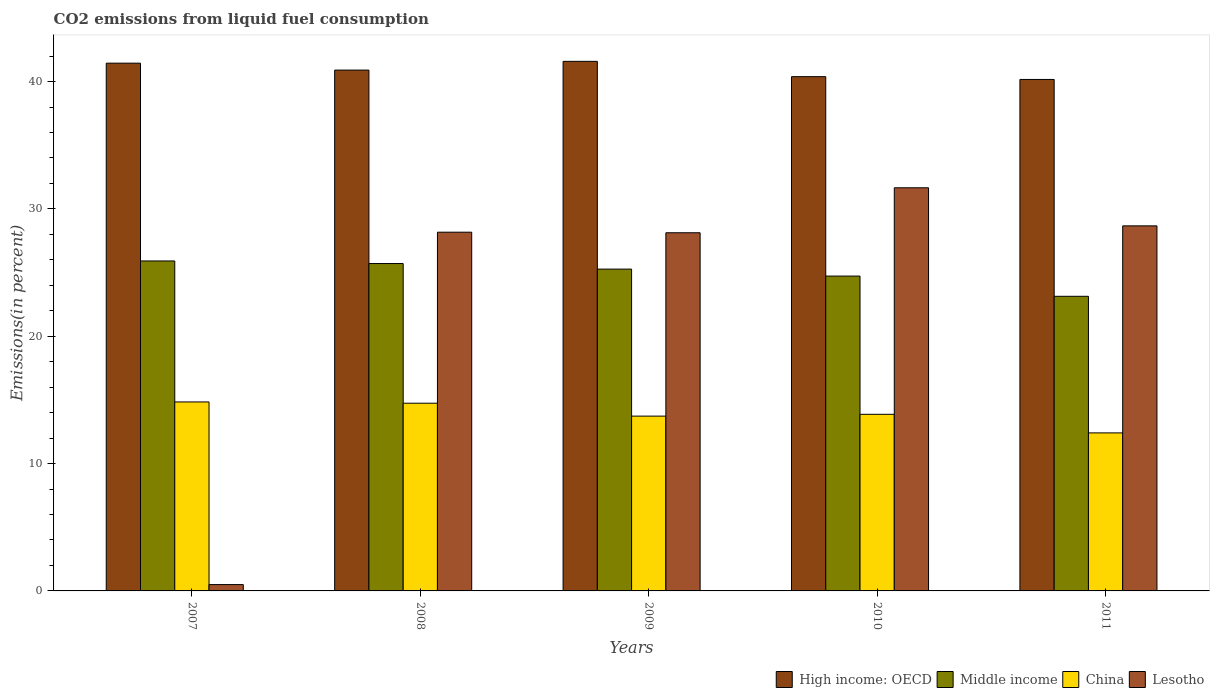How many groups of bars are there?
Provide a succinct answer. 5. Are the number of bars per tick equal to the number of legend labels?
Ensure brevity in your answer.  Yes. How many bars are there on the 1st tick from the left?
Make the answer very short. 4. How many bars are there on the 2nd tick from the right?
Your response must be concise. 4. What is the label of the 5th group of bars from the left?
Give a very brief answer. 2011. In how many cases, is the number of bars for a given year not equal to the number of legend labels?
Offer a terse response. 0. What is the total CO2 emitted in High income: OECD in 2011?
Your answer should be compact. 40.16. Across all years, what is the maximum total CO2 emitted in Lesotho?
Your response must be concise. 31.66. Across all years, what is the minimum total CO2 emitted in China?
Make the answer very short. 12.41. In which year was the total CO2 emitted in Lesotho maximum?
Offer a very short reply. 2010. In which year was the total CO2 emitted in China minimum?
Ensure brevity in your answer.  2011. What is the total total CO2 emitted in China in the graph?
Keep it short and to the point. 69.58. What is the difference between the total CO2 emitted in High income: OECD in 2008 and that in 2011?
Provide a succinct answer. 0.74. What is the difference between the total CO2 emitted in Lesotho in 2008 and the total CO2 emitted in Middle income in 2010?
Make the answer very short. 3.45. What is the average total CO2 emitted in China per year?
Give a very brief answer. 13.92. In the year 2007, what is the difference between the total CO2 emitted in China and total CO2 emitted in Middle income?
Provide a short and direct response. -11.07. In how many years, is the total CO2 emitted in China greater than 20 %?
Your answer should be compact. 0. What is the ratio of the total CO2 emitted in Lesotho in 2008 to that in 2011?
Your answer should be very brief. 0.98. Is the difference between the total CO2 emitted in China in 2009 and 2010 greater than the difference between the total CO2 emitted in Middle income in 2009 and 2010?
Provide a short and direct response. No. What is the difference between the highest and the second highest total CO2 emitted in China?
Offer a very short reply. 0.1. What is the difference between the highest and the lowest total CO2 emitted in Lesotho?
Make the answer very short. 31.16. Is the sum of the total CO2 emitted in Middle income in 2008 and 2009 greater than the maximum total CO2 emitted in High income: OECD across all years?
Your answer should be very brief. Yes. What does the 2nd bar from the left in 2008 represents?
Ensure brevity in your answer.  Middle income. What does the 1st bar from the right in 2011 represents?
Offer a terse response. Lesotho. How many bars are there?
Provide a succinct answer. 20. Are all the bars in the graph horizontal?
Your answer should be very brief. No. Are the values on the major ticks of Y-axis written in scientific E-notation?
Ensure brevity in your answer.  No. Does the graph contain any zero values?
Your answer should be very brief. No. How many legend labels are there?
Provide a succinct answer. 4. What is the title of the graph?
Your answer should be compact. CO2 emissions from liquid fuel consumption. What is the label or title of the X-axis?
Provide a succinct answer. Years. What is the label or title of the Y-axis?
Your answer should be very brief. Emissions(in percent). What is the Emissions(in percent) of High income: OECD in 2007?
Offer a very short reply. 41.44. What is the Emissions(in percent) in Middle income in 2007?
Offer a very short reply. 25.91. What is the Emissions(in percent) of China in 2007?
Ensure brevity in your answer.  14.84. What is the Emissions(in percent) in Lesotho in 2007?
Provide a short and direct response. 0.5. What is the Emissions(in percent) in High income: OECD in 2008?
Your answer should be compact. 40.9. What is the Emissions(in percent) in Middle income in 2008?
Your answer should be compact. 25.71. What is the Emissions(in percent) of China in 2008?
Ensure brevity in your answer.  14.74. What is the Emissions(in percent) of Lesotho in 2008?
Make the answer very short. 28.17. What is the Emissions(in percent) of High income: OECD in 2009?
Offer a terse response. 41.58. What is the Emissions(in percent) in Middle income in 2009?
Your response must be concise. 25.27. What is the Emissions(in percent) of China in 2009?
Your answer should be very brief. 13.73. What is the Emissions(in percent) in Lesotho in 2009?
Offer a very short reply. 28.12. What is the Emissions(in percent) of High income: OECD in 2010?
Provide a succinct answer. 40.38. What is the Emissions(in percent) of Middle income in 2010?
Offer a very short reply. 24.72. What is the Emissions(in percent) of China in 2010?
Give a very brief answer. 13.87. What is the Emissions(in percent) in Lesotho in 2010?
Your answer should be very brief. 31.66. What is the Emissions(in percent) in High income: OECD in 2011?
Your answer should be compact. 40.16. What is the Emissions(in percent) in Middle income in 2011?
Give a very brief answer. 23.13. What is the Emissions(in percent) in China in 2011?
Your response must be concise. 12.41. What is the Emissions(in percent) in Lesotho in 2011?
Offer a very short reply. 28.67. Across all years, what is the maximum Emissions(in percent) in High income: OECD?
Provide a short and direct response. 41.58. Across all years, what is the maximum Emissions(in percent) of Middle income?
Make the answer very short. 25.91. Across all years, what is the maximum Emissions(in percent) of China?
Your response must be concise. 14.84. Across all years, what is the maximum Emissions(in percent) of Lesotho?
Keep it short and to the point. 31.66. Across all years, what is the minimum Emissions(in percent) of High income: OECD?
Make the answer very short. 40.16. Across all years, what is the minimum Emissions(in percent) in Middle income?
Keep it short and to the point. 23.13. Across all years, what is the minimum Emissions(in percent) in China?
Give a very brief answer. 12.41. Across all years, what is the minimum Emissions(in percent) in Lesotho?
Offer a terse response. 0.5. What is the total Emissions(in percent) in High income: OECD in the graph?
Ensure brevity in your answer.  204.47. What is the total Emissions(in percent) in Middle income in the graph?
Your response must be concise. 124.75. What is the total Emissions(in percent) of China in the graph?
Your answer should be compact. 69.58. What is the total Emissions(in percent) in Lesotho in the graph?
Keep it short and to the point. 117.11. What is the difference between the Emissions(in percent) in High income: OECD in 2007 and that in 2008?
Provide a short and direct response. 0.54. What is the difference between the Emissions(in percent) in Middle income in 2007 and that in 2008?
Provide a short and direct response. 0.2. What is the difference between the Emissions(in percent) of China in 2007 and that in 2008?
Ensure brevity in your answer.  0.1. What is the difference between the Emissions(in percent) in Lesotho in 2007 and that in 2008?
Your answer should be compact. -27.67. What is the difference between the Emissions(in percent) in High income: OECD in 2007 and that in 2009?
Your answer should be very brief. -0.14. What is the difference between the Emissions(in percent) in Middle income in 2007 and that in 2009?
Offer a terse response. 0.64. What is the difference between the Emissions(in percent) in China in 2007 and that in 2009?
Offer a very short reply. 1.11. What is the difference between the Emissions(in percent) in Lesotho in 2007 and that in 2009?
Make the answer very short. -27.63. What is the difference between the Emissions(in percent) of High income: OECD in 2007 and that in 2010?
Provide a succinct answer. 1.06. What is the difference between the Emissions(in percent) of Middle income in 2007 and that in 2010?
Make the answer very short. 1.19. What is the difference between the Emissions(in percent) of China in 2007 and that in 2010?
Make the answer very short. 0.97. What is the difference between the Emissions(in percent) of Lesotho in 2007 and that in 2010?
Your answer should be compact. -31.16. What is the difference between the Emissions(in percent) in High income: OECD in 2007 and that in 2011?
Your response must be concise. 1.28. What is the difference between the Emissions(in percent) in Middle income in 2007 and that in 2011?
Your response must be concise. 2.78. What is the difference between the Emissions(in percent) in China in 2007 and that in 2011?
Offer a terse response. 2.43. What is the difference between the Emissions(in percent) in Lesotho in 2007 and that in 2011?
Offer a very short reply. -28.17. What is the difference between the Emissions(in percent) in High income: OECD in 2008 and that in 2009?
Provide a succinct answer. -0.69. What is the difference between the Emissions(in percent) of Middle income in 2008 and that in 2009?
Your answer should be very brief. 0.44. What is the difference between the Emissions(in percent) of China in 2008 and that in 2009?
Make the answer very short. 1.01. What is the difference between the Emissions(in percent) of Lesotho in 2008 and that in 2009?
Your answer should be very brief. 0.04. What is the difference between the Emissions(in percent) in High income: OECD in 2008 and that in 2010?
Keep it short and to the point. 0.52. What is the difference between the Emissions(in percent) of Middle income in 2008 and that in 2010?
Offer a terse response. 0.98. What is the difference between the Emissions(in percent) of China in 2008 and that in 2010?
Offer a terse response. 0.87. What is the difference between the Emissions(in percent) in Lesotho in 2008 and that in 2010?
Give a very brief answer. -3.49. What is the difference between the Emissions(in percent) of High income: OECD in 2008 and that in 2011?
Ensure brevity in your answer.  0.74. What is the difference between the Emissions(in percent) of Middle income in 2008 and that in 2011?
Provide a succinct answer. 2.57. What is the difference between the Emissions(in percent) in China in 2008 and that in 2011?
Make the answer very short. 2.33. What is the difference between the Emissions(in percent) in Lesotho in 2008 and that in 2011?
Keep it short and to the point. -0.5. What is the difference between the Emissions(in percent) of High income: OECD in 2009 and that in 2010?
Give a very brief answer. 1.2. What is the difference between the Emissions(in percent) in Middle income in 2009 and that in 2010?
Your response must be concise. 0.55. What is the difference between the Emissions(in percent) of China in 2009 and that in 2010?
Offer a very short reply. -0.14. What is the difference between the Emissions(in percent) in Lesotho in 2009 and that in 2010?
Offer a terse response. -3.53. What is the difference between the Emissions(in percent) of High income: OECD in 2009 and that in 2011?
Your response must be concise. 1.42. What is the difference between the Emissions(in percent) in Middle income in 2009 and that in 2011?
Your response must be concise. 2.14. What is the difference between the Emissions(in percent) of China in 2009 and that in 2011?
Offer a terse response. 1.32. What is the difference between the Emissions(in percent) of Lesotho in 2009 and that in 2011?
Keep it short and to the point. -0.54. What is the difference between the Emissions(in percent) in High income: OECD in 2010 and that in 2011?
Offer a terse response. 0.22. What is the difference between the Emissions(in percent) of Middle income in 2010 and that in 2011?
Offer a terse response. 1.59. What is the difference between the Emissions(in percent) of China in 2010 and that in 2011?
Provide a short and direct response. 1.46. What is the difference between the Emissions(in percent) in Lesotho in 2010 and that in 2011?
Offer a very short reply. 2.99. What is the difference between the Emissions(in percent) of High income: OECD in 2007 and the Emissions(in percent) of Middle income in 2008?
Provide a short and direct response. 15.73. What is the difference between the Emissions(in percent) in High income: OECD in 2007 and the Emissions(in percent) in China in 2008?
Provide a succinct answer. 26.7. What is the difference between the Emissions(in percent) of High income: OECD in 2007 and the Emissions(in percent) of Lesotho in 2008?
Make the answer very short. 13.27. What is the difference between the Emissions(in percent) of Middle income in 2007 and the Emissions(in percent) of China in 2008?
Ensure brevity in your answer.  11.17. What is the difference between the Emissions(in percent) in Middle income in 2007 and the Emissions(in percent) in Lesotho in 2008?
Ensure brevity in your answer.  -2.26. What is the difference between the Emissions(in percent) of China in 2007 and the Emissions(in percent) of Lesotho in 2008?
Your answer should be very brief. -13.33. What is the difference between the Emissions(in percent) of High income: OECD in 2007 and the Emissions(in percent) of Middle income in 2009?
Keep it short and to the point. 16.17. What is the difference between the Emissions(in percent) of High income: OECD in 2007 and the Emissions(in percent) of China in 2009?
Offer a terse response. 27.72. What is the difference between the Emissions(in percent) in High income: OECD in 2007 and the Emissions(in percent) in Lesotho in 2009?
Ensure brevity in your answer.  13.32. What is the difference between the Emissions(in percent) in Middle income in 2007 and the Emissions(in percent) in China in 2009?
Your answer should be compact. 12.18. What is the difference between the Emissions(in percent) of Middle income in 2007 and the Emissions(in percent) of Lesotho in 2009?
Keep it short and to the point. -2.21. What is the difference between the Emissions(in percent) in China in 2007 and the Emissions(in percent) in Lesotho in 2009?
Offer a very short reply. -13.29. What is the difference between the Emissions(in percent) of High income: OECD in 2007 and the Emissions(in percent) of Middle income in 2010?
Your response must be concise. 16.72. What is the difference between the Emissions(in percent) of High income: OECD in 2007 and the Emissions(in percent) of China in 2010?
Offer a terse response. 27.57. What is the difference between the Emissions(in percent) in High income: OECD in 2007 and the Emissions(in percent) in Lesotho in 2010?
Offer a very short reply. 9.79. What is the difference between the Emissions(in percent) in Middle income in 2007 and the Emissions(in percent) in China in 2010?
Provide a short and direct response. 12.04. What is the difference between the Emissions(in percent) of Middle income in 2007 and the Emissions(in percent) of Lesotho in 2010?
Your response must be concise. -5.74. What is the difference between the Emissions(in percent) of China in 2007 and the Emissions(in percent) of Lesotho in 2010?
Offer a terse response. -16.82. What is the difference between the Emissions(in percent) in High income: OECD in 2007 and the Emissions(in percent) in Middle income in 2011?
Provide a succinct answer. 18.31. What is the difference between the Emissions(in percent) in High income: OECD in 2007 and the Emissions(in percent) in China in 2011?
Offer a very short reply. 29.03. What is the difference between the Emissions(in percent) of High income: OECD in 2007 and the Emissions(in percent) of Lesotho in 2011?
Your response must be concise. 12.78. What is the difference between the Emissions(in percent) in Middle income in 2007 and the Emissions(in percent) in China in 2011?
Your answer should be very brief. 13.5. What is the difference between the Emissions(in percent) of Middle income in 2007 and the Emissions(in percent) of Lesotho in 2011?
Keep it short and to the point. -2.76. What is the difference between the Emissions(in percent) in China in 2007 and the Emissions(in percent) in Lesotho in 2011?
Offer a terse response. -13.83. What is the difference between the Emissions(in percent) of High income: OECD in 2008 and the Emissions(in percent) of Middle income in 2009?
Offer a very short reply. 15.63. What is the difference between the Emissions(in percent) of High income: OECD in 2008 and the Emissions(in percent) of China in 2009?
Keep it short and to the point. 27.17. What is the difference between the Emissions(in percent) in High income: OECD in 2008 and the Emissions(in percent) in Lesotho in 2009?
Your answer should be very brief. 12.77. What is the difference between the Emissions(in percent) in Middle income in 2008 and the Emissions(in percent) in China in 2009?
Your answer should be very brief. 11.98. What is the difference between the Emissions(in percent) in Middle income in 2008 and the Emissions(in percent) in Lesotho in 2009?
Provide a short and direct response. -2.42. What is the difference between the Emissions(in percent) of China in 2008 and the Emissions(in percent) of Lesotho in 2009?
Offer a very short reply. -13.39. What is the difference between the Emissions(in percent) in High income: OECD in 2008 and the Emissions(in percent) in Middle income in 2010?
Your answer should be compact. 16.18. What is the difference between the Emissions(in percent) in High income: OECD in 2008 and the Emissions(in percent) in China in 2010?
Offer a very short reply. 27.03. What is the difference between the Emissions(in percent) of High income: OECD in 2008 and the Emissions(in percent) of Lesotho in 2010?
Your answer should be compact. 9.24. What is the difference between the Emissions(in percent) in Middle income in 2008 and the Emissions(in percent) in China in 2010?
Provide a short and direct response. 11.84. What is the difference between the Emissions(in percent) in Middle income in 2008 and the Emissions(in percent) in Lesotho in 2010?
Ensure brevity in your answer.  -5.95. What is the difference between the Emissions(in percent) of China in 2008 and the Emissions(in percent) of Lesotho in 2010?
Offer a terse response. -16.92. What is the difference between the Emissions(in percent) of High income: OECD in 2008 and the Emissions(in percent) of Middle income in 2011?
Ensure brevity in your answer.  17.77. What is the difference between the Emissions(in percent) in High income: OECD in 2008 and the Emissions(in percent) in China in 2011?
Your answer should be compact. 28.49. What is the difference between the Emissions(in percent) of High income: OECD in 2008 and the Emissions(in percent) of Lesotho in 2011?
Give a very brief answer. 12.23. What is the difference between the Emissions(in percent) of Middle income in 2008 and the Emissions(in percent) of China in 2011?
Give a very brief answer. 13.3. What is the difference between the Emissions(in percent) in Middle income in 2008 and the Emissions(in percent) in Lesotho in 2011?
Give a very brief answer. -2.96. What is the difference between the Emissions(in percent) of China in 2008 and the Emissions(in percent) of Lesotho in 2011?
Your answer should be very brief. -13.93. What is the difference between the Emissions(in percent) in High income: OECD in 2009 and the Emissions(in percent) in Middle income in 2010?
Offer a very short reply. 16.86. What is the difference between the Emissions(in percent) of High income: OECD in 2009 and the Emissions(in percent) of China in 2010?
Your answer should be compact. 27.72. What is the difference between the Emissions(in percent) in High income: OECD in 2009 and the Emissions(in percent) in Lesotho in 2010?
Offer a terse response. 9.93. What is the difference between the Emissions(in percent) in Middle income in 2009 and the Emissions(in percent) in China in 2010?
Ensure brevity in your answer.  11.4. What is the difference between the Emissions(in percent) in Middle income in 2009 and the Emissions(in percent) in Lesotho in 2010?
Provide a short and direct response. -6.38. What is the difference between the Emissions(in percent) in China in 2009 and the Emissions(in percent) in Lesotho in 2010?
Your answer should be very brief. -17.93. What is the difference between the Emissions(in percent) of High income: OECD in 2009 and the Emissions(in percent) of Middle income in 2011?
Your answer should be very brief. 18.45. What is the difference between the Emissions(in percent) of High income: OECD in 2009 and the Emissions(in percent) of China in 2011?
Provide a succinct answer. 29.18. What is the difference between the Emissions(in percent) in High income: OECD in 2009 and the Emissions(in percent) in Lesotho in 2011?
Keep it short and to the point. 12.92. What is the difference between the Emissions(in percent) in Middle income in 2009 and the Emissions(in percent) in China in 2011?
Keep it short and to the point. 12.86. What is the difference between the Emissions(in percent) in Middle income in 2009 and the Emissions(in percent) in Lesotho in 2011?
Offer a very short reply. -3.4. What is the difference between the Emissions(in percent) of China in 2009 and the Emissions(in percent) of Lesotho in 2011?
Provide a short and direct response. -14.94. What is the difference between the Emissions(in percent) in High income: OECD in 2010 and the Emissions(in percent) in Middle income in 2011?
Make the answer very short. 17.25. What is the difference between the Emissions(in percent) of High income: OECD in 2010 and the Emissions(in percent) of China in 2011?
Offer a very short reply. 27.97. What is the difference between the Emissions(in percent) of High income: OECD in 2010 and the Emissions(in percent) of Lesotho in 2011?
Your response must be concise. 11.72. What is the difference between the Emissions(in percent) of Middle income in 2010 and the Emissions(in percent) of China in 2011?
Provide a short and direct response. 12.32. What is the difference between the Emissions(in percent) in Middle income in 2010 and the Emissions(in percent) in Lesotho in 2011?
Ensure brevity in your answer.  -3.94. What is the difference between the Emissions(in percent) of China in 2010 and the Emissions(in percent) of Lesotho in 2011?
Your answer should be compact. -14.8. What is the average Emissions(in percent) in High income: OECD per year?
Your answer should be very brief. 40.89. What is the average Emissions(in percent) of Middle income per year?
Provide a short and direct response. 24.95. What is the average Emissions(in percent) of China per year?
Your answer should be very brief. 13.92. What is the average Emissions(in percent) in Lesotho per year?
Provide a succinct answer. 23.42. In the year 2007, what is the difference between the Emissions(in percent) of High income: OECD and Emissions(in percent) of Middle income?
Provide a succinct answer. 15.53. In the year 2007, what is the difference between the Emissions(in percent) of High income: OECD and Emissions(in percent) of China?
Give a very brief answer. 26.6. In the year 2007, what is the difference between the Emissions(in percent) in High income: OECD and Emissions(in percent) in Lesotho?
Your response must be concise. 40.95. In the year 2007, what is the difference between the Emissions(in percent) in Middle income and Emissions(in percent) in China?
Keep it short and to the point. 11.07. In the year 2007, what is the difference between the Emissions(in percent) of Middle income and Emissions(in percent) of Lesotho?
Make the answer very short. 25.41. In the year 2007, what is the difference between the Emissions(in percent) of China and Emissions(in percent) of Lesotho?
Offer a very short reply. 14.34. In the year 2008, what is the difference between the Emissions(in percent) of High income: OECD and Emissions(in percent) of Middle income?
Offer a terse response. 15.19. In the year 2008, what is the difference between the Emissions(in percent) of High income: OECD and Emissions(in percent) of China?
Give a very brief answer. 26.16. In the year 2008, what is the difference between the Emissions(in percent) in High income: OECD and Emissions(in percent) in Lesotho?
Your answer should be very brief. 12.73. In the year 2008, what is the difference between the Emissions(in percent) in Middle income and Emissions(in percent) in China?
Ensure brevity in your answer.  10.97. In the year 2008, what is the difference between the Emissions(in percent) of Middle income and Emissions(in percent) of Lesotho?
Make the answer very short. -2.46. In the year 2008, what is the difference between the Emissions(in percent) in China and Emissions(in percent) in Lesotho?
Provide a short and direct response. -13.43. In the year 2009, what is the difference between the Emissions(in percent) in High income: OECD and Emissions(in percent) in Middle income?
Your answer should be compact. 16.31. In the year 2009, what is the difference between the Emissions(in percent) of High income: OECD and Emissions(in percent) of China?
Provide a succinct answer. 27.86. In the year 2009, what is the difference between the Emissions(in percent) of High income: OECD and Emissions(in percent) of Lesotho?
Keep it short and to the point. 13.46. In the year 2009, what is the difference between the Emissions(in percent) in Middle income and Emissions(in percent) in China?
Ensure brevity in your answer.  11.55. In the year 2009, what is the difference between the Emissions(in percent) of Middle income and Emissions(in percent) of Lesotho?
Give a very brief answer. -2.85. In the year 2009, what is the difference between the Emissions(in percent) of China and Emissions(in percent) of Lesotho?
Ensure brevity in your answer.  -14.4. In the year 2010, what is the difference between the Emissions(in percent) in High income: OECD and Emissions(in percent) in Middle income?
Your answer should be compact. 15.66. In the year 2010, what is the difference between the Emissions(in percent) of High income: OECD and Emissions(in percent) of China?
Your answer should be compact. 26.51. In the year 2010, what is the difference between the Emissions(in percent) in High income: OECD and Emissions(in percent) in Lesotho?
Offer a very short reply. 8.73. In the year 2010, what is the difference between the Emissions(in percent) in Middle income and Emissions(in percent) in China?
Offer a terse response. 10.85. In the year 2010, what is the difference between the Emissions(in percent) in Middle income and Emissions(in percent) in Lesotho?
Your answer should be compact. -6.93. In the year 2010, what is the difference between the Emissions(in percent) in China and Emissions(in percent) in Lesotho?
Ensure brevity in your answer.  -17.79. In the year 2011, what is the difference between the Emissions(in percent) of High income: OECD and Emissions(in percent) of Middle income?
Offer a very short reply. 17.03. In the year 2011, what is the difference between the Emissions(in percent) in High income: OECD and Emissions(in percent) in China?
Your answer should be compact. 27.76. In the year 2011, what is the difference between the Emissions(in percent) in High income: OECD and Emissions(in percent) in Lesotho?
Your answer should be very brief. 11.5. In the year 2011, what is the difference between the Emissions(in percent) in Middle income and Emissions(in percent) in China?
Keep it short and to the point. 10.73. In the year 2011, what is the difference between the Emissions(in percent) of Middle income and Emissions(in percent) of Lesotho?
Offer a very short reply. -5.53. In the year 2011, what is the difference between the Emissions(in percent) of China and Emissions(in percent) of Lesotho?
Keep it short and to the point. -16.26. What is the ratio of the Emissions(in percent) in High income: OECD in 2007 to that in 2008?
Give a very brief answer. 1.01. What is the ratio of the Emissions(in percent) of Middle income in 2007 to that in 2008?
Provide a short and direct response. 1.01. What is the ratio of the Emissions(in percent) in China in 2007 to that in 2008?
Your answer should be compact. 1.01. What is the ratio of the Emissions(in percent) in Lesotho in 2007 to that in 2008?
Give a very brief answer. 0.02. What is the ratio of the Emissions(in percent) in High income: OECD in 2007 to that in 2009?
Your answer should be compact. 1. What is the ratio of the Emissions(in percent) in Middle income in 2007 to that in 2009?
Keep it short and to the point. 1.03. What is the ratio of the Emissions(in percent) in China in 2007 to that in 2009?
Ensure brevity in your answer.  1.08. What is the ratio of the Emissions(in percent) of Lesotho in 2007 to that in 2009?
Ensure brevity in your answer.  0.02. What is the ratio of the Emissions(in percent) in High income: OECD in 2007 to that in 2010?
Your answer should be compact. 1.03. What is the ratio of the Emissions(in percent) of Middle income in 2007 to that in 2010?
Your response must be concise. 1.05. What is the ratio of the Emissions(in percent) of China in 2007 to that in 2010?
Offer a very short reply. 1.07. What is the ratio of the Emissions(in percent) of Lesotho in 2007 to that in 2010?
Your answer should be compact. 0.02. What is the ratio of the Emissions(in percent) of High income: OECD in 2007 to that in 2011?
Your answer should be compact. 1.03. What is the ratio of the Emissions(in percent) of Middle income in 2007 to that in 2011?
Offer a terse response. 1.12. What is the ratio of the Emissions(in percent) in China in 2007 to that in 2011?
Your response must be concise. 1.2. What is the ratio of the Emissions(in percent) of Lesotho in 2007 to that in 2011?
Provide a succinct answer. 0.02. What is the ratio of the Emissions(in percent) of High income: OECD in 2008 to that in 2009?
Give a very brief answer. 0.98. What is the ratio of the Emissions(in percent) in Middle income in 2008 to that in 2009?
Offer a very short reply. 1.02. What is the ratio of the Emissions(in percent) in China in 2008 to that in 2009?
Offer a very short reply. 1.07. What is the ratio of the Emissions(in percent) in High income: OECD in 2008 to that in 2010?
Provide a short and direct response. 1.01. What is the ratio of the Emissions(in percent) of Middle income in 2008 to that in 2010?
Your answer should be very brief. 1.04. What is the ratio of the Emissions(in percent) in China in 2008 to that in 2010?
Make the answer very short. 1.06. What is the ratio of the Emissions(in percent) of Lesotho in 2008 to that in 2010?
Keep it short and to the point. 0.89. What is the ratio of the Emissions(in percent) in High income: OECD in 2008 to that in 2011?
Your answer should be very brief. 1.02. What is the ratio of the Emissions(in percent) in Middle income in 2008 to that in 2011?
Make the answer very short. 1.11. What is the ratio of the Emissions(in percent) in China in 2008 to that in 2011?
Make the answer very short. 1.19. What is the ratio of the Emissions(in percent) in Lesotho in 2008 to that in 2011?
Give a very brief answer. 0.98. What is the ratio of the Emissions(in percent) of High income: OECD in 2009 to that in 2010?
Provide a succinct answer. 1.03. What is the ratio of the Emissions(in percent) in Middle income in 2009 to that in 2010?
Ensure brevity in your answer.  1.02. What is the ratio of the Emissions(in percent) of China in 2009 to that in 2010?
Keep it short and to the point. 0.99. What is the ratio of the Emissions(in percent) of Lesotho in 2009 to that in 2010?
Provide a succinct answer. 0.89. What is the ratio of the Emissions(in percent) of High income: OECD in 2009 to that in 2011?
Ensure brevity in your answer.  1.04. What is the ratio of the Emissions(in percent) of Middle income in 2009 to that in 2011?
Your answer should be very brief. 1.09. What is the ratio of the Emissions(in percent) in China in 2009 to that in 2011?
Provide a short and direct response. 1.11. What is the ratio of the Emissions(in percent) of Lesotho in 2009 to that in 2011?
Provide a succinct answer. 0.98. What is the ratio of the Emissions(in percent) in High income: OECD in 2010 to that in 2011?
Ensure brevity in your answer.  1.01. What is the ratio of the Emissions(in percent) in Middle income in 2010 to that in 2011?
Your response must be concise. 1.07. What is the ratio of the Emissions(in percent) of China in 2010 to that in 2011?
Offer a very short reply. 1.12. What is the ratio of the Emissions(in percent) of Lesotho in 2010 to that in 2011?
Ensure brevity in your answer.  1.1. What is the difference between the highest and the second highest Emissions(in percent) of High income: OECD?
Your answer should be very brief. 0.14. What is the difference between the highest and the second highest Emissions(in percent) of Middle income?
Provide a short and direct response. 0.2. What is the difference between the highest and the second highest Emissions(in percent) of China?
Provide a succinct answer. 0.1. What is the difference between the highest and the second highest Emissions(in percent) of Lesotho?
Provide a short and direct response. 2.99. What is the difference between the highest and the lowest Emissions(in percent) of High income: OECD?
Provide a short and direct response. 1.42. What is the difference between the highest and the lowest Emissions(in percent) in Middle income?
Offer a very short reply. 2.78. What is the difference between the highest and the lowest Emissions(in percent) in China?
Your response must be concise. 2.43. What is the difference between the highest and the lowest Emissions(in percent) of Lesotho?
Provide a succinct answer. 31.16. 